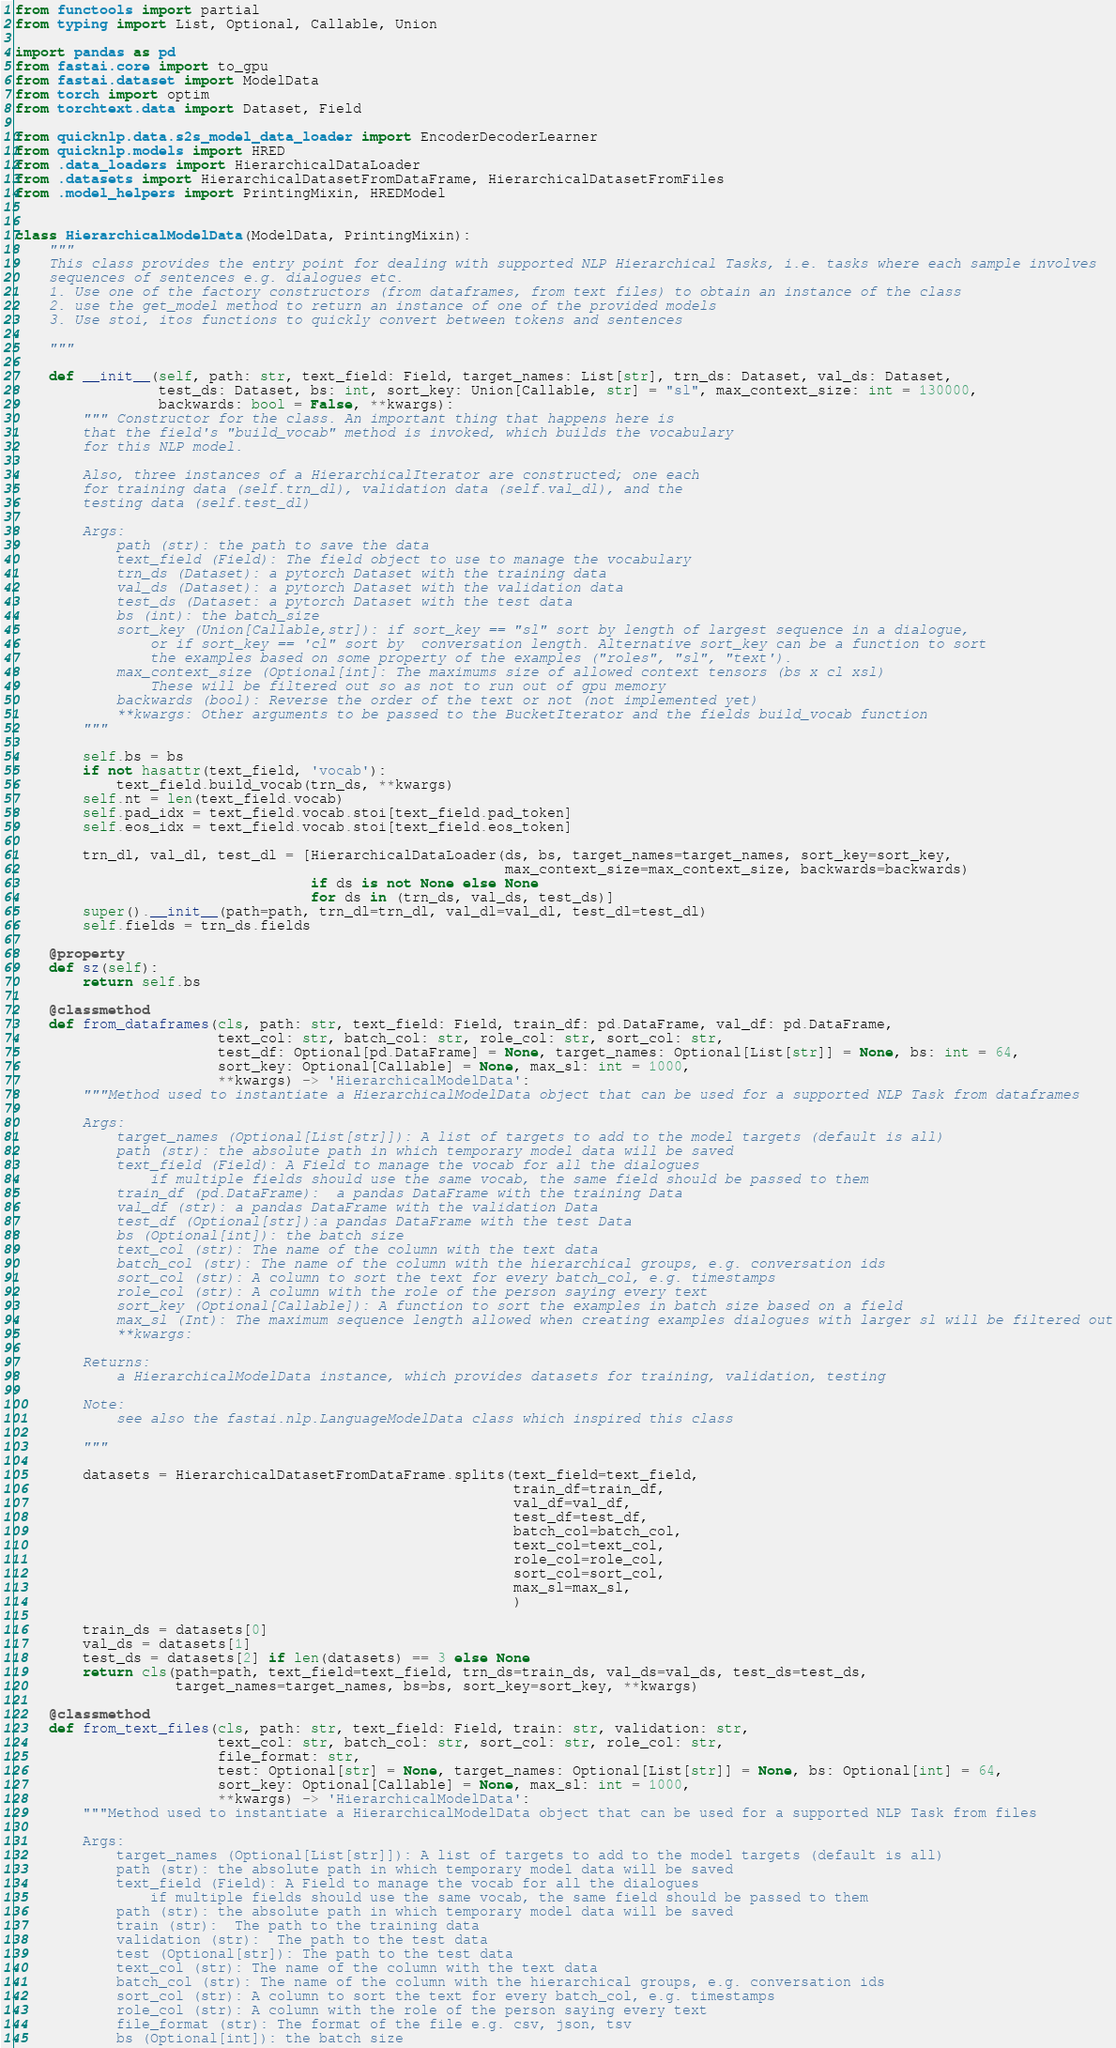<code> <loc_0><loc_0><loc_500><loc_500><_Python_>from functools import partial
from typing import List, Optional, Callable, Union

import pandas as pd
from fastai.core import to_gpu
from fastai.dataset import ModelData
from torch import optim
from torchtext.data import Dataset, Field

from quicknlp.data.s2s_model_data_loader import EncoderDecoderLearner
from quicknlp.models import HRED
from .data_loaders import HierarchicalDataLoader
from .datasets import HierarchicalDatasetFromDataFrame, HierarchicalDatasetFromFiles
from .model_helpers import PrintingMixin, HREDModel


class HierarchicalModelData(ModelData, PrintingMixin):
    """
    This class provides the entry point for dealing with supported NLP Hierarchical Tasks, i.e. tasks where each sample involves
    sequences of sentences e.g. dialogues etc.
    1. Use one of the factory constructors (from dataframes, from text files) to obtain an instance of the class
    2. use the get_model method to return an instance of one of the provided models
    3. Use stoi, itos functions to quickly convert between tokens and sentences

    """

    def __init__(self, path: str, text_field: Field, target_names: List[str], trn_ds: Dataset, val_ds: Dataset,
                 test_ds: Dataset, bs: int, sort_key: Union[Callable, str] = "sl", max_context_size: int = 130000,
                 backwards: bool = False, **kwargs):
        """ Constructor for the class. An important thing that happens here is
        that the field's "build_vocab" method is invoked, which builds the vocabulary
        for this NLP model.

        Also, three instances of a HierarchicalIterator are constructed; one each
        for training data (self.trn_dl), validation data (self.val_dl), and the
        testing data (self.test_dl)

        Args:
            path (str): the path to save the data
            text_field (Field): The field object to use to manage the vocabulary
            trn_ds (Dataset): a pytorch Dataset with the training data
            val_ds (Dataset): a pytorch Dataset with the validation data
            test_ds (Dataset: a pytorch Dataset with the test data
            bs (int): the batch_size
            sort_key (Union[Callable,str]): if sort_key == "sl" sort by length of largest sequence in a dialogue,
                or if sort_key == 'cl" sort by  conversation length. Alternative sort_key can be a function to sort
                the examples based on some property of the examples ("roles", "sl", "text').
            max_context_size (Optional[int]: The maximums size of allowed context tensors (bs x cl xsl)
                These will be filtered out so as not to run out of gpu memory
            backwards (bool): Reverse the order of the text or not (not implemented yet)
            **kwargs: Other arguments to be passed to the BucketIterator and the fields build_vocab function
        """

        self.bs = bs
        if not hasattr(text_field, 'vocab'):
            text_field.build_vocab(trn_ds, **kwargs)
        self.nt = len(text_field.vocab)
        self.pad_idx = text_field.vocab.stoi[text_field.pad_token]
        self.eos_idx = text_field.vocab.stoi[text_field.eos_token]

        trn_dl, val_dl, test_dl = [HierarchicalDataLoader(ds, bs, target_names=target_names, sort_key=sort_key,
                                                          max_context_size=max_context_size, backwards=backwards)
                                   if ds is not None else None
                                   for ds in (trn_ds, val_ds, test_ds)]
        super().__init__(path=path, trn_dl=trn_dl, val_dl=val_dl, test_dl=test_dl)
        self.fields = trn_ds.fields

    @property
    def sz(self):
        return self.bs

    @classmethod
    def from_dataframes(cls, path: str, text_field: Field, train_df: pd.DataFrame, val_df: pd.DataFrame,
                        text_col: str, batch_col: str, role_col: str, sort_col: str,
                        test_df: Optional[pd.DataFrame] = None, target_names: Optional[List[str]] = None, bs: int = 64,
                        sort_key: Optional[Callable] = None, max_sl: int = 1000,
                        **kwargs) -> 'HierarchicalModelData':
        """Method used to instantiate a HierarchicalModelData object that can be used for a supported NLP Task from dataframes

        Args:
            target_names (Optional[List[str]]): A list of targets to add to the model targets (default is all)
            path (str): the absolute path in which temporary model data will be saved
            text_field (Field): A Field to manage the vocab for all the dialogues
                if multiple fields should use the same vocab, the same field should be passed to them
            train_df (pd.DataFrame):  a pandas DataFrame with the training Data
            val_df (str): a pandas DataFrame with the validation Data
            test_df (Optional[str]):a pandas DataFrame with the test Data
            bs (Optional[int]): the batch size
            text_col (str): The name of the column with the text data
            batch_col (str): The name of the column with the hierarchical groups, e.g. conversation ids
            sort_col (str): A column to sort the text for every batch_col, e.g. timestamps
            role_col (str): A column with the role of the person saying every text
            sort_key (Optional[Callable]): A function to sort the examples in batch size based on a field
            max_sl (Int): The maximum sequence length allowed when creating examples dialogues with larger sl will be filtered out
            **kwargs:

        Returns:
            a HierarchicalModelData instance, which provides datasets for training, validation, testing

        Note:
            see also the fastai.nlp.LanguageModelData class which inspired this class

        """

        datasets = HierarchicalDatasetFromDataFrame.splits(text_field=text_field,
                                                           train_df=train_df,
                                                           val_df=val_df,
                                                           test_df=test_df,
                                                           batch_col=batch_col,
                                                           text_col=text_col,
                                                           role_col=role_col,
                                                           sort_col=sort_col,
                                                           max_sl=max_sl,
                                                           )

        train_ds = datasets[0]
        val_ds = datasets[1]
        test_ds = datasets[2] if len(datasets) == 3 else None
        return cls(path=path, text_field=text_field, trn_ds=train_ds, val_ds=val_ds, test_ds=test_ds,
                   target_names=target_names, bs=bs, sort_key=sort_key, **kwargs)

    @classmethod
    def from_text_files(cls, path: str, text_field: Field, train: str, validation: str,
                        text_col: str, batch_col: str, sort_col: str, role_col: str,
                        file_format: str,
                        test: Optional[str] = None, target_names: Optional[List[str]] = None, bs: Optional[int] = 64,
                        sort_key: Optional[Callable] = None, max_sl: int = 1000,
                        **kwargs) -> 'HierarchicalModelData':
        """Method used to instantiate a HierarchicalModelData object that can be used for a supported NLP Task from files

        Args:
            target_names (Optional[List[str]]): A list of targets to add to the model targets (default is all)
            path (str): the absolute path in which temporary model data will be saved
            text_field (Field): A Field to manage the vocab for all the dialogues
                if multiple fields should use the same vocab, the same field should be passed to them
            path (str): the absolute path in which temporary model data will be saved
            train (str):  The path to the training data
            validation (str):  The path to the test data
            test (Optional[str]): The path to the test data
            text_col (str): The name of the column with the text data
            batch_col (str): The name of the column with the hierarchical groups, e.g. conversation ids
            sort_col (str): A column to sort the text for every batch_col, e.g. timestamps
            role_col (str): A column with the role of the person saying every text
            file_format (str): The format of the file e.g. csv, json, tsv
            bs (Optional[int]): the batch size</code> 